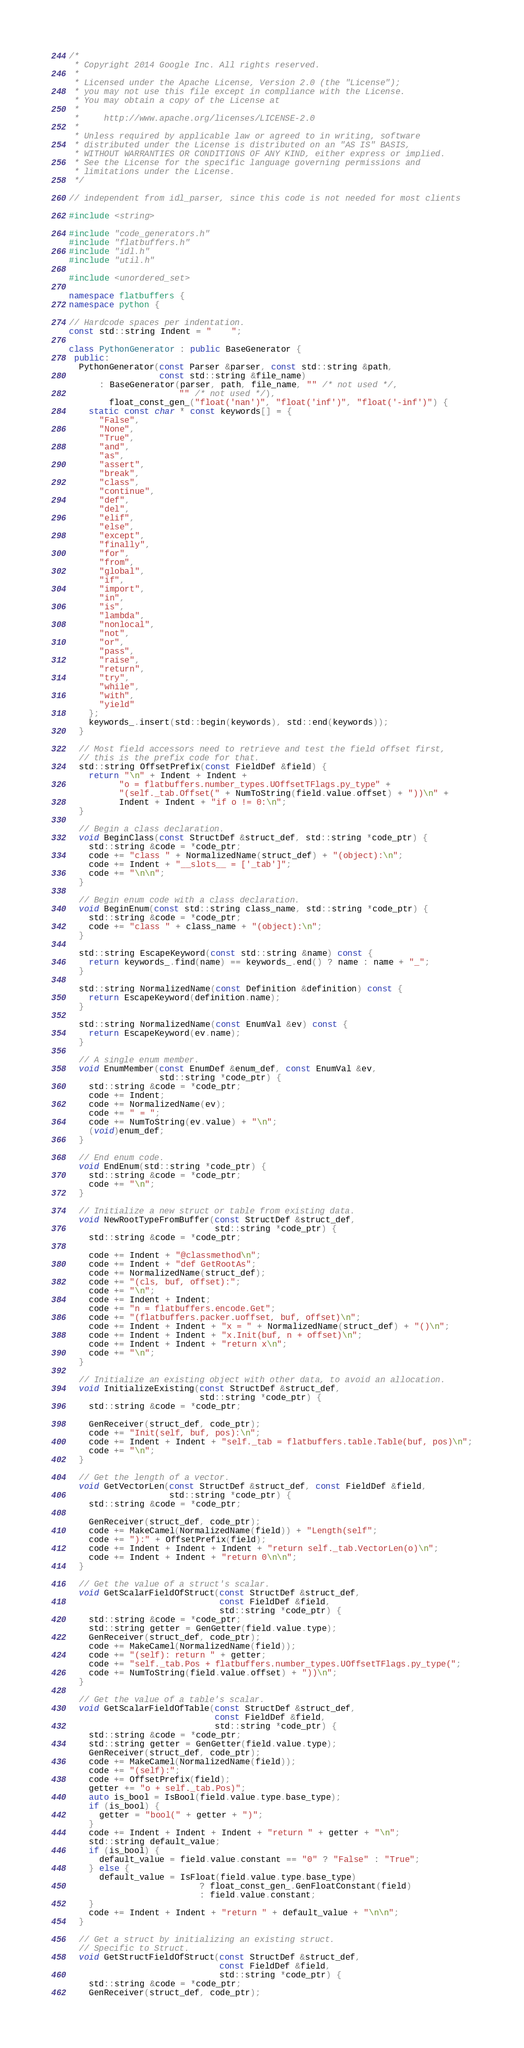Convert code to text. <code><loc_0><loc_0><loc_500><loc_500><_C++_>/*
 * Copyright 2014 Google Inc. All rights reserved.
 *
 * Licensed under the Apache License, Version 2.0 (the "License");
 * you may not use this file except in compliance with the License.
 * You may obtain a copy of the License at
 *
 *     http://www.apache.org/licenses/LICENSE-2.0
 *
 * Unless required by applicable law or agreed to in writing, software
 * distributed under the License is distributed on an "AS IS" BASIS,
 * WITHOUT WARRANTIES OR CONDITIONS OF ANY KIND, either express or implied.
 * See the License for the specific language governing permissions and
 * limitations under the License.
 */

// independent from idl_parser, since this code is not needed for most clients

#include <string>

#include "code_generators.h"
#include "flatbuffers.h"
#include "idl.h"
#include "util.h"

#include <unordered_set>

namespace flatbuffers {
namespace python {

// Hardcode spaces per indentation.
const std::string Indent = "    ";

class PythonGenerator : public BaseGenerator {
 public:
  PythonGenerator(const Parser &parser, const std::string &path,
                  const std::string &file_name)
      : BaseGenerator(parser, path, file_name, "" /* not used */,
                      "" /* not used */),
        float_const_gen_("float('nan')", "float('inf')", "float('-inf')") {
    static const char * const keywords[] = {
      "False",
      "None",
      "True",
      "and",
      "as",
      "assert",
      "break",
      "class",
      "continue",
      "def",
      "del",
      "elif",
      "else",
      "except",
      "finally",
      "for",
      "from",
      "global",
      "if",
      "import",
      "in",
      "is",
      "lambda",
      "nonlocal",
      "not",
      "or",
      "pass",
      "raise",
      "return",
      "try",
      "while",
      "with",
      "yield"
    };
    keywords_.insert(std::begin(keywords), std::end(keywords));
  }

  // Most field accessors need to retrieve and test the field offset first,
  // this is the prefix code for that.
  std::string OffsetPrefix(const FieldDef &field) {
    return "\n" + Indent + Indent +
          "o = flatbuffers.number_types.UOffsetTFlags.py_type" +
          "(self._tab.Offset(" + NumToString(field.value.offset) + "))\n" +
          Indent + Indent + "if o != 0:\n";
  }

  // Begin a class declaration.
  void BeginClass(const StructDef &struct_def, std::string *code_ptr) {
    std::string &code = *code_ptr;
    code += "class " + NormalizedName(struct_def) + "(object):\n";
    code += Indent + "__slots__ = ['_tab']";
    code += "\n\n";
  }

  // Begin enum code with a class declaration.
  void BeginEnum(const std::string class_name, std::string *code_ptr) {
    std::string &code = *code_ptr;
    code += "class " + class_name + "(object):\n";
  }

  std::string EscapeKeyword(const std::string &name) const {
    return keywords_.find(name) == keywords_.end() ? name : name + "_";
  }

  std::string NormalizedName(const Definition &definition) const {
    return EscapeKeyword(definition.name);
  }

  std::string NormalizedName(const EnumVal &ev) const {
    return EscapeKeyword(ev.name);
  }

  // A single enum member.
  void EnumMember(const EnumDef &enum_def, const EnumVal &ev,
                  std::string *code_ptr) {
    std::string &code = *code_ptr;
    code += Indent;
    code += NormalizedName(ev);
    code += " = ";
    code += NumToString(ev.value) + "\n";
    (void)enum_def;
  }

  // End enum code.
  void EndEnum(std::string *code_ptr) {
    std::string &code = *code_ptr;
    code += "\n";
  }

  // Initialize a new struct or table from existing data.
  void NewRootTypeFromBuffer(const StructDef &struct_def,
                             std::string *code_ptr) {
    std::string &code = *code_ptr;

    code += Indent + "@classmethod\n";
    code += Indent + "def GetRootAs";
    code += NormalizedName(struct_def);
    code += "(cls, buf, offset):";
    code += "\n";
    code += Indent + Indent;
    code += "n = flatbuffers.encode.Get";
    code += "(flatbuffers.packer.uoffset, buf, offset)\n";
    code += Indent + Indent + "x = " + NormalizedName(struct_def) + "()\n";
    code += Indent + Indent + "x.Init(buf, n + offset)\n";
    code += Indent + Indent + "return x\n";
    code += "\n";
  }

  // Initialize an existing object with other data, to avoid an allocation.
  void InitializeExisting(const StructDef &struct_def,
                          std::string *code_ptr) {
    std::string &code = *code_ptr;

    GenReceiver(struct_def, code_ptr);
    code += "Init(self, buf, pos):\n";
    code += Indent + Indent + "self._tab = flatbuffers.table.Table(buf, pos)\n";
    code += "\n";
  }

  // Get the length of a vector.
  void GetVectorLen(const StructDef &struct_def, const FieldDef &field,
                    std::string *code_ptr) {
    std::string &code = *code_ptr;

    GenReceiver(struct_def, code_ptr);
    code += MakeCamel(NormalizedName(field)) + "Length(self";
    code += "):" + OffsetPrefix(field);
    code += Indent + Indent + Indent + "return self._tab.VectorLen(o)\n";
    code += Indent + Indent + "return 0\n\n";
  }

  // Get the value of a struct's scalar.
  void GetScalarFieldOfStruct(const StructDef &struct_def,
                              const FieldDef &field,
                              std::string *code_ptr) {
    std::string &code = *code_ptr;
    std::string getter = GenGetter(field.value.type);
    GenReceiver(struct_def, code_ptr);
    code += MakeCamel(NormalizedName(field));
    code += "(self): return " + getter;
    code += "self._tab.Pos + flatbuffers.number_types.UOffsetTFlags.py_type(";
    code += NumToString(field.value.offset) + "))\n";
  }

  // Get the value of a table's scalar.
  void GetScalarFieldOfTable(const StructDef &struct_def,
                             const FieldDef &field,
                             std::string *code_ptr) {
    std::string &code = *code_ptr;
    std::string getter = GenGetter(field.value.type);
    GenReceiver(struct_def, code_ptr);
    code += MakeCamel(NormalizedName(field));
    code += "(self):";
    code += OffsetPrefix(field);
    getter += "o + self._tab.Pos)";
    auto is_bool = IsBool(field.value.type.base_type);
    if (is_bool) {
      getter = "bool(" + getter + ")";
    }
    code += Indent + Indent + Indent + "return " + getter + "\n";
    std::string default_value;
    if (is_bool) {
      default_value = field.value.constant == "0" ? "False" : "True";
    } else {
      default_value = IsFloat(field.value.type.base_type)
                          ? float_const_gen_.GenFloatConstant(field)
                          : field.value.constant;
    }
    code += Indent + Indent + "return " + default_value + "\n\n";
  }

  // Get a struct by initializing an existing struct.
  // Specific to Struct.
  void GetStructFieldOfStruct(const StructDef &struct_def,
                              const FieldDef &field,
                              std::string *code_ptr) {
    std::string &code = *code_ptr;
    GenReceiver(struct_def, code_ptr);</code> 